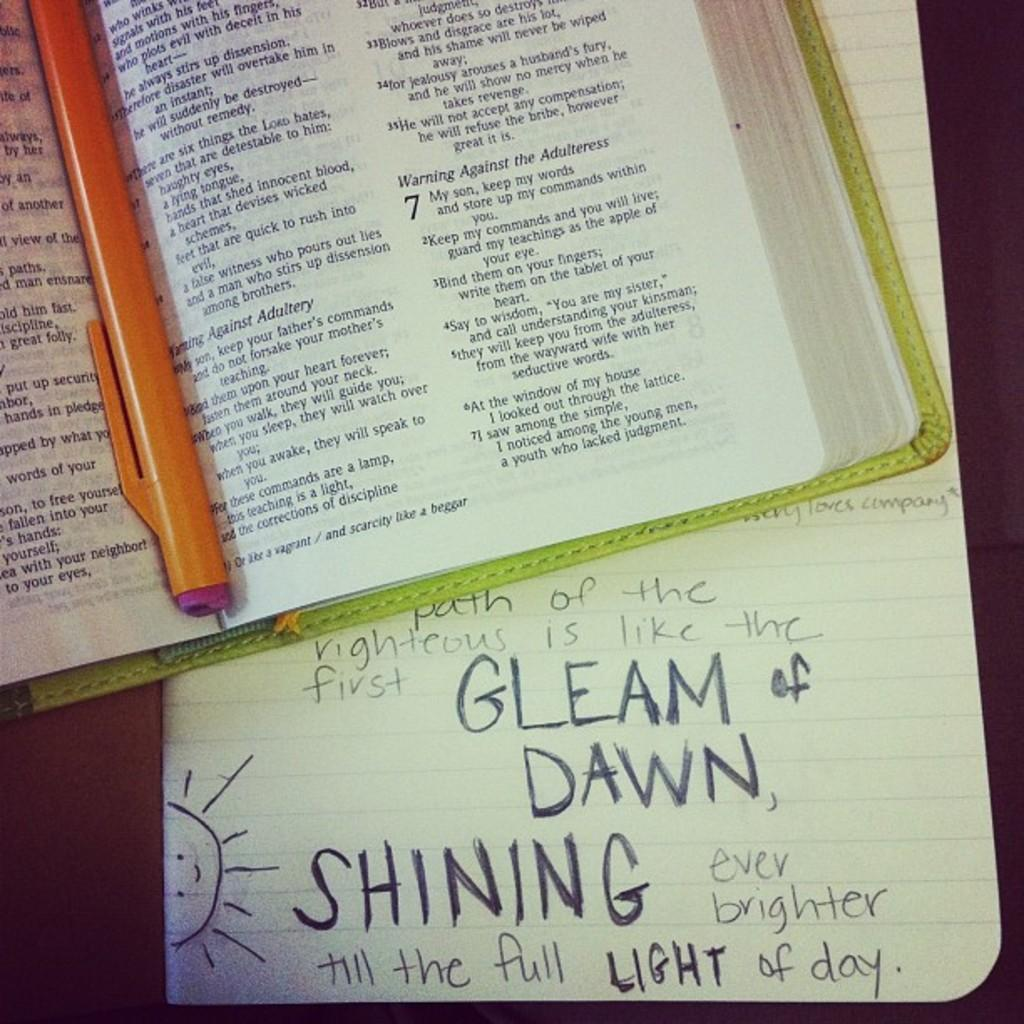<image>
Relay a brief, clear account of the picture shown. Open book with a paper under it that says "Gleam of Dawn". 